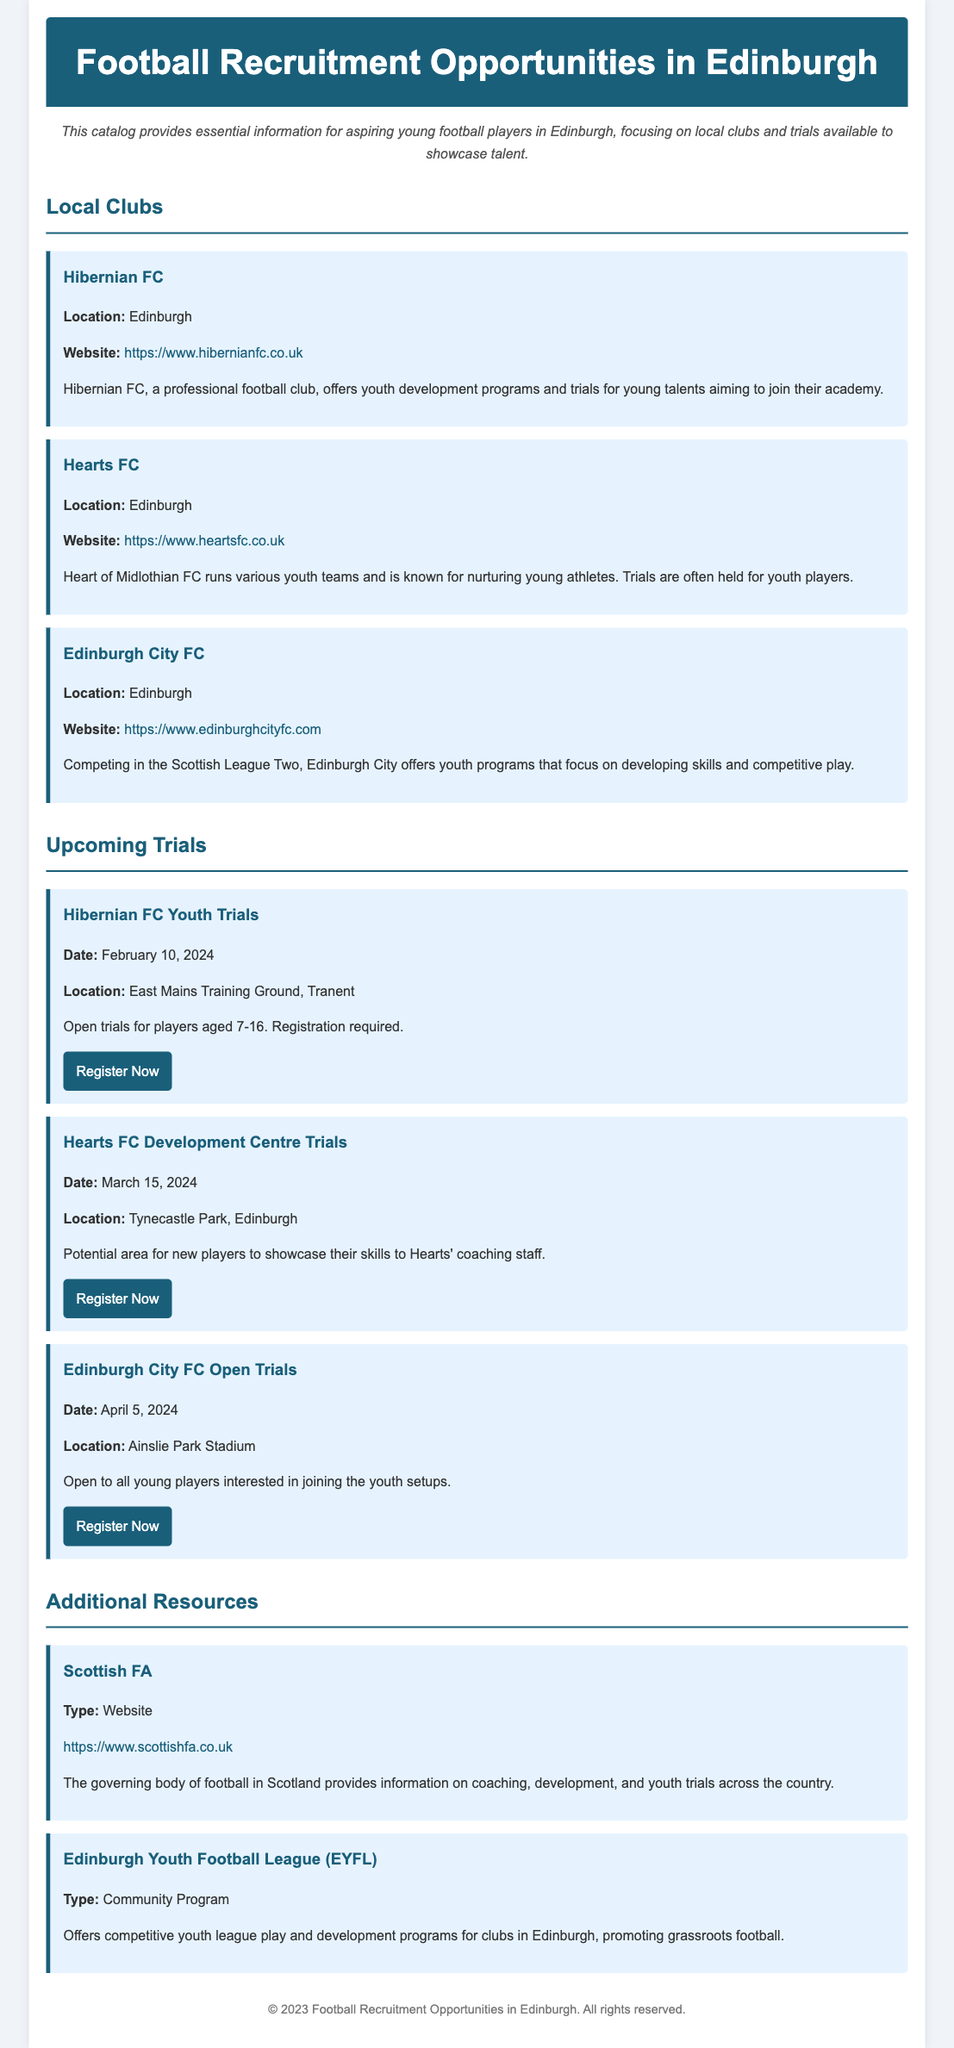What is the date for the Hibernian FC Youth Trials? The document specifies that the Hibernian FC Youth Trials are scheduled for February 10, 2024.
Answer: February 10, 2024 Where is the location for Hearts FC Development Centre Trials? The location mentioned for the Hearts FC Development Centre Trials is Tynecastle Park, Edinburgh.
Answer: Tynecastle Park, Edinburgh What age group can register for the Hibernian FC Youth Trials? The document indicates that players aged 7-16 can register for the Hibernian FC Youth Trials.
Answer: 7-16 What type of resource is the Edinburgh Youth Football League (EYFL)? The document categorizes the Edinburgh Youth Football League (EYFL) as a community program.
Answer: Community Program Which club offers trials for youth players and is located in Edinburgh? The document lists Hibernian FC, Hearts FC, and Edinburgh City FC as clubs offering trials in Edinburgh.
Answer: Hibernian FC, Hearts FC, Edinburgh City FC What is the website for Edinburgh City FC? The website provided for Edinburgh City FC in the document is found in the club's section.
Answer: https://www.edinburghcityfc.com How many local clubs are mentioned in the document? The document lists a total of three local clubs, namely Hibernian FC, Hearts FC, and Edinburgh City FC.
Answer: Three Which organization provides information on coaching and youth trials? The Scottish FA is specified as the governing body providing information on coaching and youth trials.
Answer: Scottish FA 